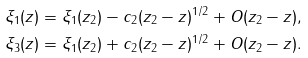<formula> <loc_0><loc_0><loc_500><loc_500>\xi _ { 1 } ( z ) & = \xi _ { 1 } ( z _ { 2 } ) - c _ { 2 } ( z _ { 2 } - z ) ^ { 1 / 2 } + O ( z _ { 2 } - z ) , \\ \xi _ { 3 } ( z ) & = \xi _ { 1 } ( z _ { 2 } ) + c _ { 2 } ( z _ { 2 } - z ) ^ { 1 / 2 } + O ( z _ { 2 } - z ) .</formula> 